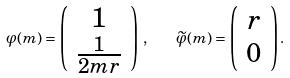<formula> <loc_0><loc_0><loc_500><loc_500>\varphi ( m ) = \left ( \begin{array} { c } 1 \\ \frac { 1 } { 2 m r } \end{array} \right ) \, , \quad \widetilde { \varphi } ( m ) = \left ( \begin{array} { c } r \\ 0 \end{array} \right ) .</formula> 